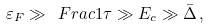Convert formula to latex. <formula><loc_0><loc_0><loc_500><loc_500>\varepsilon _ { F } \gg \ F r a c { 1 } { \tau } \gg E _ { c } \gg \bar { \Delta } \, ,</formula> 